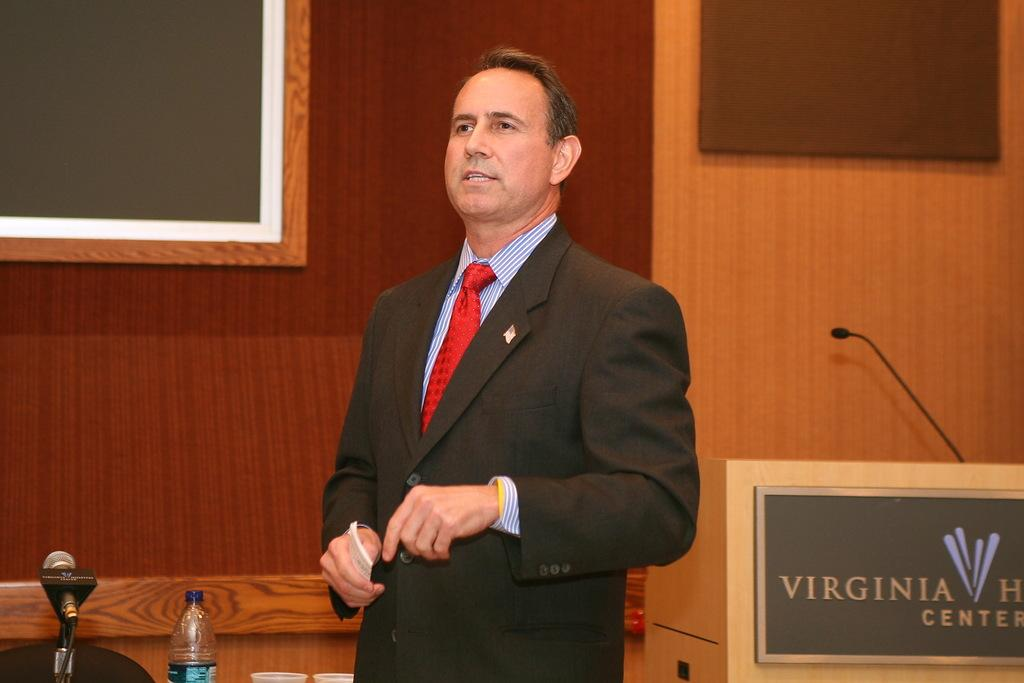<image>
Present a compact description of the photo's key features. A man giving a talk next to a lectern that says Virginia something Center. 